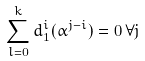Convert formula to latex. <formula><loc_0><loc_0><loc_500><loc_500>\sum _ { l = 0 } ^ { k } d _ { 1 } ^ { i } ( \alpha ^ { j - i } ) = 0 \, \forall j</formula> 